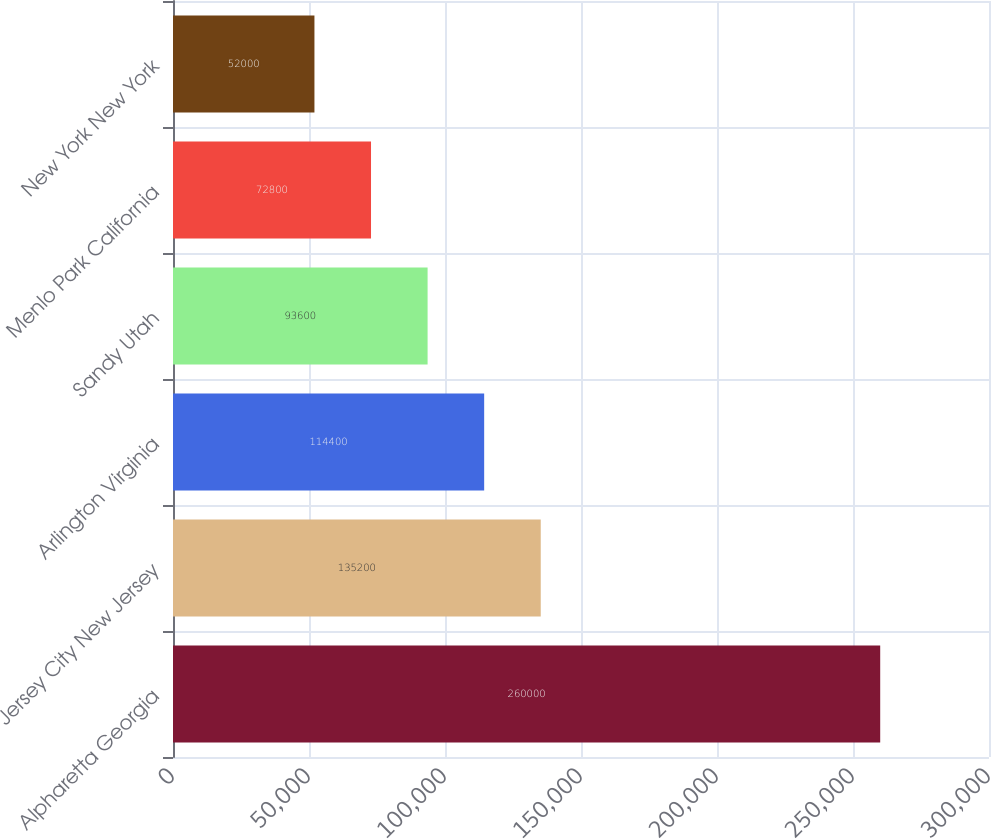<chart> <loc_0><loc_0><loc_500><loc_500><bar_chart><fcel>Alpharetta Georgia<fcel>Jersey City New Jersey<fcel>Arlington Virginia<fcel>Sandy Utah<fcel>Menlo Park California<fcel>New York New York<nl><fcel>260000<fcel>135200<fcel>114400<fcel>93600<fcel>72800<fcel>52000<nl></chart> 